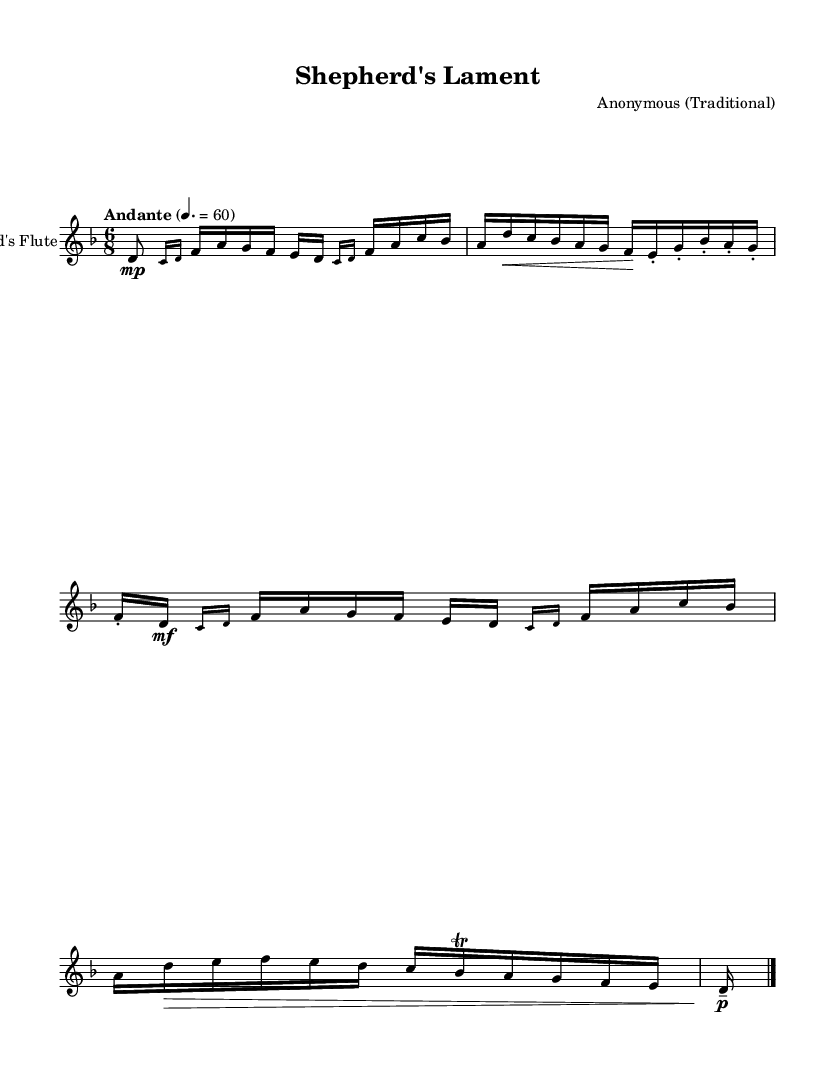What is the key signature of this music? The key signature is indicated at the beginning of the staff, which shows one flat, meaning it is in D minor.
Answer: D minor What is the time signature of this piece? The time signature is also shown at the beginning of the piece, presented as a fraction where the top number is 6 and the bottom is 8, indicating it has six eighth notes per measure.
Answer: 6/8 What is the tempo marking for this composition? The tempo marking is found above the staff, specifying a speed of "Andante" with a metronome marking of 60 beats per minute, indicating a moderate pace.
Answer: Andante 60 Which note is the highest in the first measure? By examining the notes in the first measure, the highest pitch represented is an 'a' note, which occurs after the grace notes.
Answer: a What type of ornamentation is used in the second measure? The second measure contains grace notes, indicated by the small written notes before the main note, which embellish the melody and create a decorative effect.
Answer: Grace notes How many times does the note 'd' appear in the first section? By counting the occurrences of the note 'd' throughout the first section of the piece, it appears six times in various forms (both as a main note and as part of grace notes).
Answer: 6 